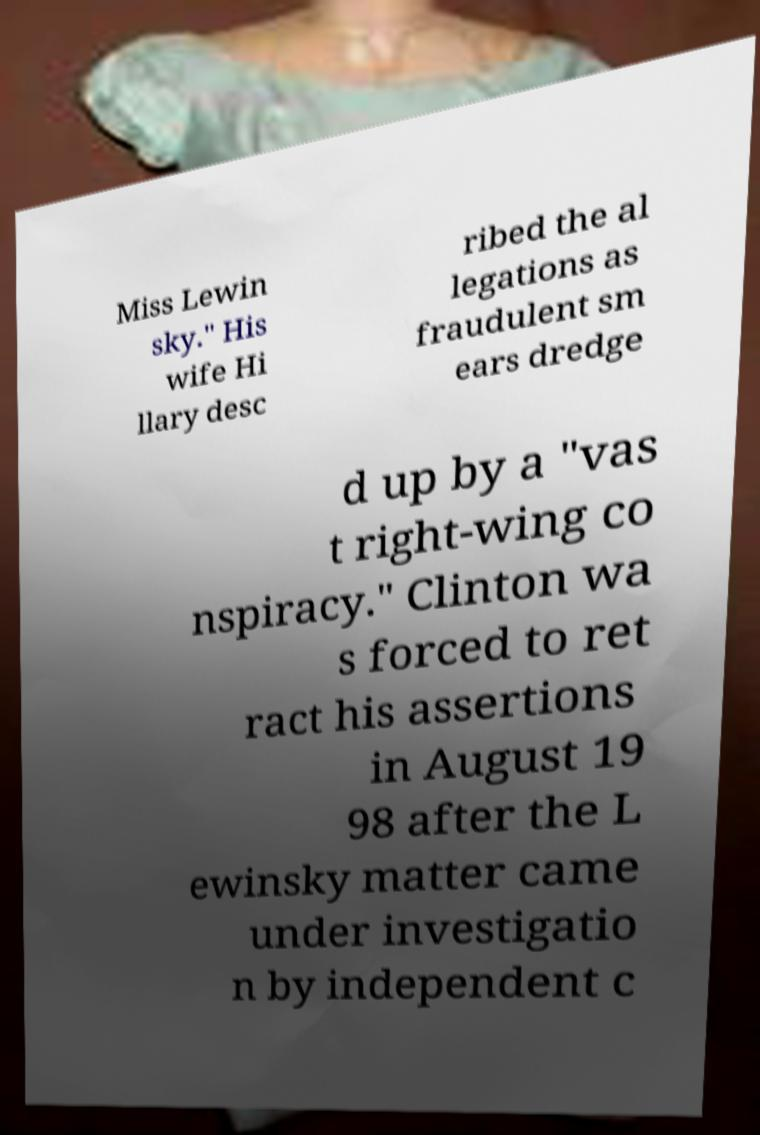What messages or text are displayed in this image? I need them in a readable, typed format. Miss Lewin sky." His wife Hi llary desc ribed the al legations as fraudulent sm ears dredge d up by a "vas t right-wing co nspiracy." Clinton wa s forced to ret ract his assertions in August 19 98 after the L ewinsky matter came under investigatio n by independent c 